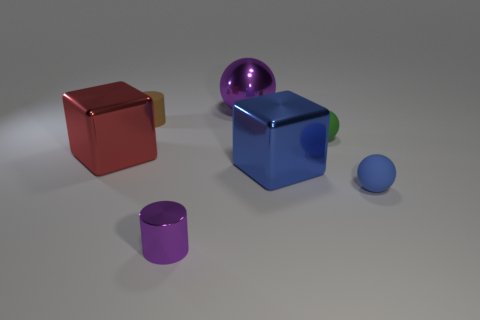Subtract all small green matte balls. How many balls are left? 2 Subtract 1 cylinders. How many cylinders are left? 1 Subtract all cyan cylinders. Subtract all blue spheres. How many cylinders are left? 2 Subtract all cyan spheres. How many purple cylinders are left? 1 Subtract all small purple things. Subtract all large yellow shiny spheres. How many objects are left? 6 Add 7 rubber spheres. How many rubber spheres are left? 9 Add 6 blue shiny balls. How many blue shiny balls exist? 6 Add 2 small things. How many objects exist? 9 Subtract all purple cylinders. How many cylinders are left? 1 Subtract 0 green cylinders. How many objects are left? 7 